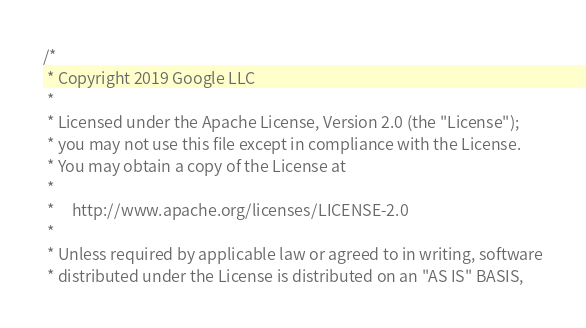<code> <loc_0><loc_0><loc_500><loc_500><_SQL_>/*
 * Copyright 2019 Google LLC
 *
 * Licensed under the Apache License, Version 2.0 (the "License");
 * you may not use this file except in compliance with the License.
 * You may obtain a copy of the License at
 *
 *     http://www.apache.org/licenses/LICENSE-2.0
 *
 * Unless required by applicable law or agreed to in writing, software
 * distributed under the License is distributed on an "AS IS" BASIS,</code> 